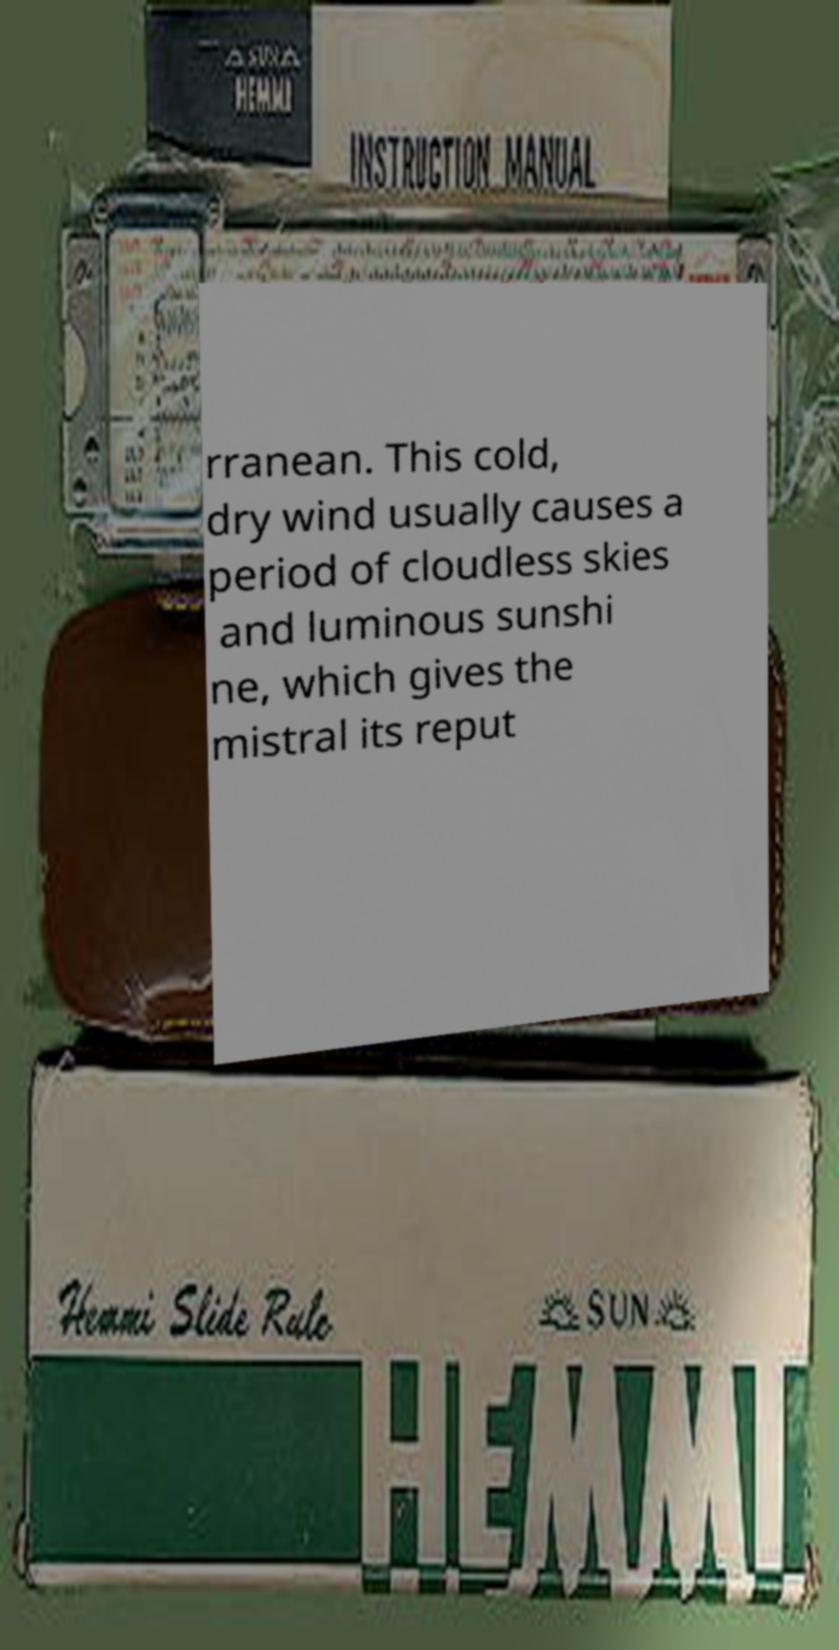What messages or text are displayed in this image? I need them in a readable, typed format. rranean. This cold, dry wind usually causes a period of cloudless skies and luminous sunshi ne, which gives the mistral its reput 